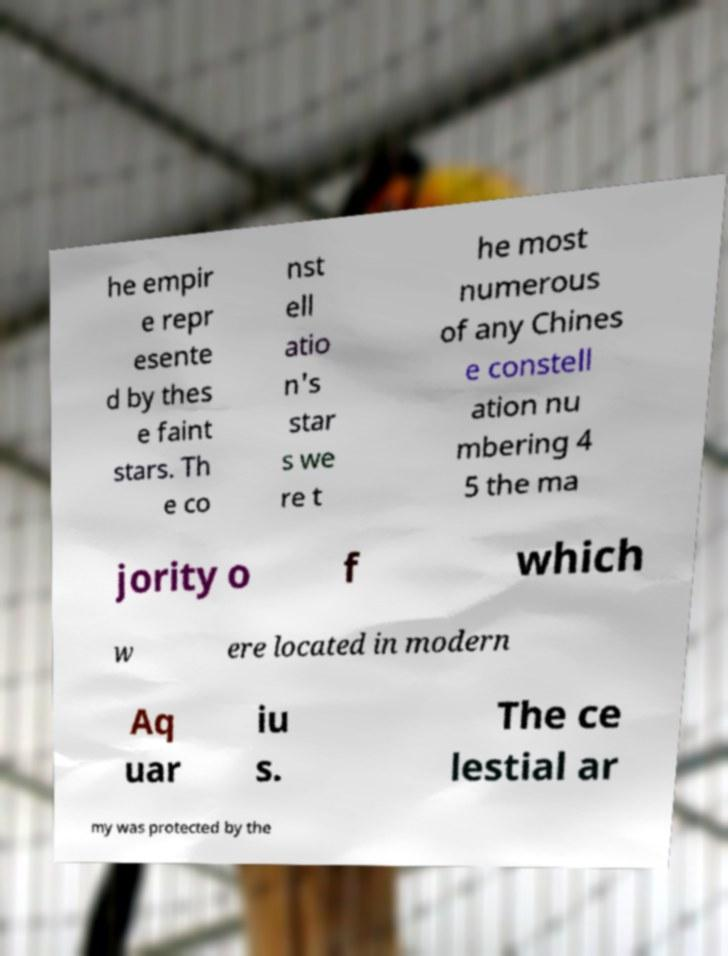Please identify and transcribe the text found in this image. he empir e repr esente d by thes e faint stars. Th e co nst ell atio n's star s we re t he most numerous of any Chines e constell ation nu mbering 4 5 the ma jority o f which w ere located in modern Aq uar iu s. The ce lestial ar my was protected by the 